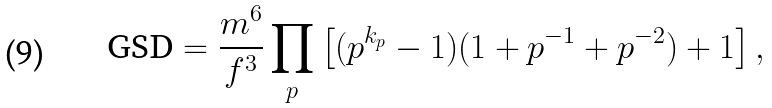<formula> <loc_0><loc_0><loc_500><loc_500>\text {GSD} = \frac { m ^ { 6 } } { f ^ { 3 } } \prod _ { p } \left [ ( p ^ { k _ { p } } - 1 ) ( 1 + p ^ { - 1 } + p ^ { - 2 } ) + 1 \right ] ,</formula> 